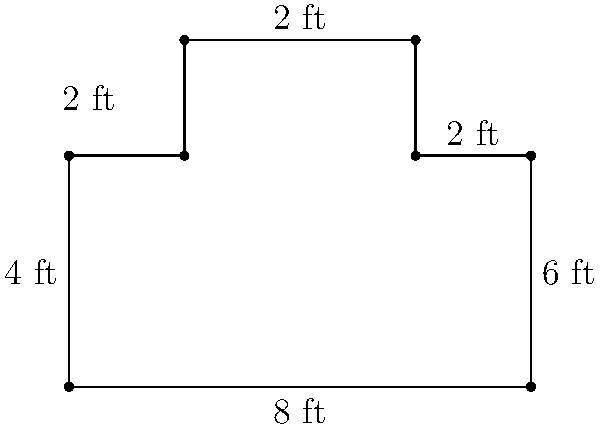As a former child actor, you're reminiscing about your old dressing room on set. The floor plan of the irregularly shaped room is shown above. What is the total area of the dressing room in square feet? To find the area of this irregularly shaped dressing room, we can break it down into rectangles:

1. Main rectangle:
   Length = 8 ft, Width = 4 ft
   Area = $8 \times 4 = 32$ sq ft

2. Upper left rectangle:
   Length = 2 ft, Width = 2 ft
   Area = $2 \times 2 = 4$ sq ft

3. Upper right rectangle:
   Length = 2 ft, Width = 2 ft
   Area = $2 \times 2 = 4$ sq ft

Total area = Sum of all rectangles
$$\text{Total Area} = 32 + 4 + 4 = 40 \text{ sq ft}$$

Therefore, the total area of the dressing room is 40 square feet.
Answer: 40 sq ft 